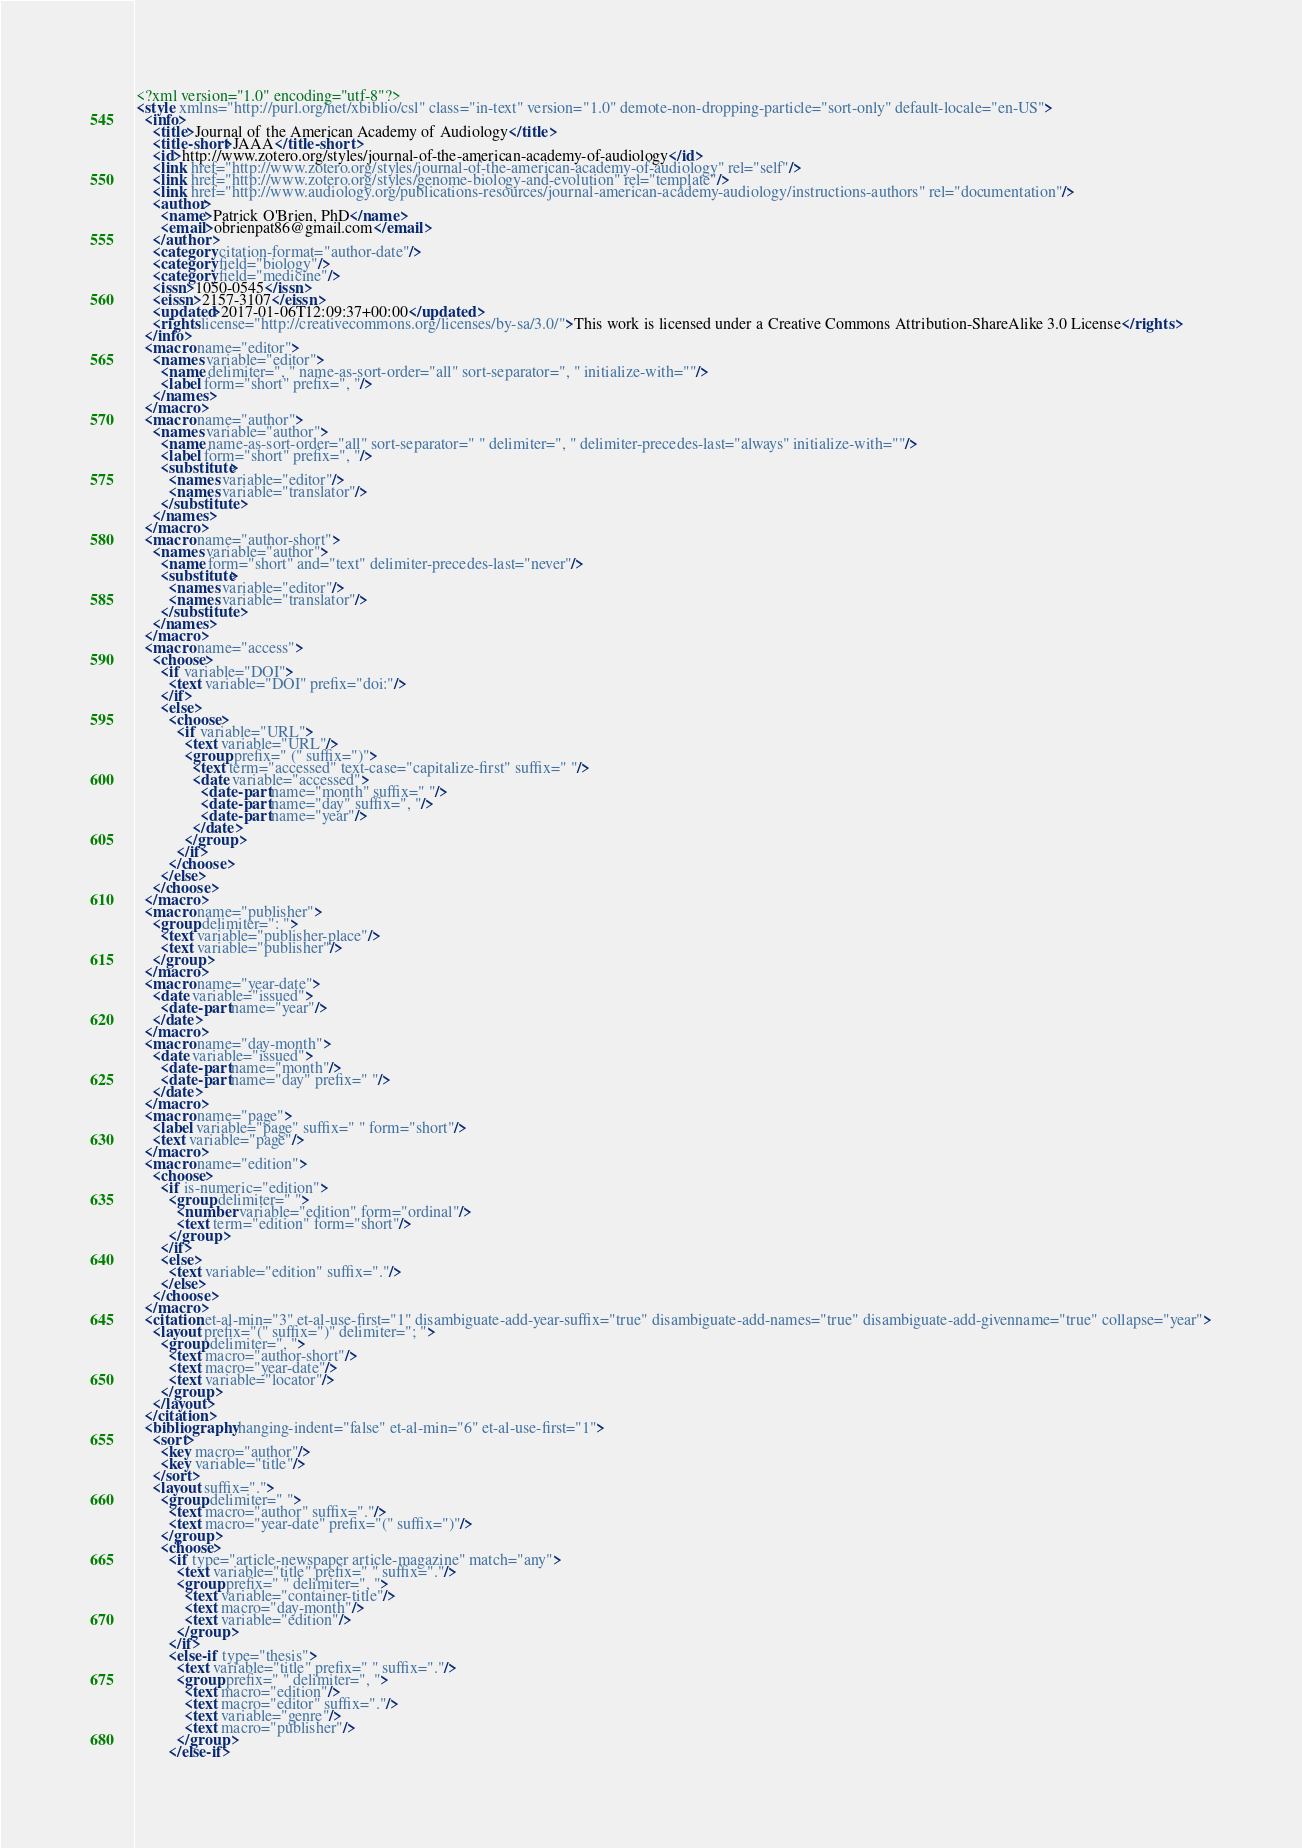<code> <loc_0><loc_0><loc_500><loc_500><_XML_><?xml version="1.0" encoding="utf-8"?>
<style xmlns="http://purl.org/net/xbiblio/csl" class="in-text" version="1.0" demote-non-dropping-particle="sort-only" default-locale="en-US">
  <info>
    <title>Journal of the American Academy of Audiology</title>
    <title-short>JAAA</title-short>
    <id>http://www.zotero.org/styles/journal-of-the-american-academy-of-audiology</id>
    <link href="http://www.zotero.org/styles/journal-of-the-american-academy-of-audiology" rel="self"/>
    <link href="http://www.zotero.org/styles/genome-biology-and-evolution" rel="template"/>
    <link href="http://www.audiology.org/publications-resources/journal-american-academy-audiology/instructions-authors" rel="documentation"/>
    <author>
      <name>Patrick O'Brien, PhD</name>
      <email>obrienpat86@gmail.com</email>
    </author>
    <category citation-format="author-date"/>
    <category field="biology"/>
    <category field="medicine"/>
    <issn>1050-0545</issn>
    <eissn>2157-3107</eissn>
    <updated>2017-01-06T12:09:37+00:00</updated>
    <rights license="http://creativecommons.org/licenses/by-sa/3.0/">This work is licensed under a Creative Commons Attribution-ShareAlike 3.0 License</rights>
  </info>
  <macro name="editor">
    <names variable="editor">
      <name delimiter=", " name-as-sort-order="all" sort-separator=", " initialize-with=""/>
      <label form="short" prefix=", "/>
    </names>
  </macro>
  <macro name="author">
    <names variable="author">
      <name name-as-sort-order="all" sort-separator=" " delimiter=", " delimiter-precedes-last="always" initialize-with=""/>
      <label form="short" prefix=", "/>
      <substitute>
        <names variable="editor"/>
        <names variable="translator"/>
      </substitute>
    </names>
  </macro>
  <macro name="author-short">
    <names variable="author">
      <name form="short" and="text" delimiter-precedes-last="never"/>
      <substitute>
        <names variable="editor"/>
        <names variable="translator"/>
      </substitute>
    </names>
  </macro>
  <macro name="access">
    <choose>
      <if variable="DOI">
        <text variable="DOI" prefix="doi:"/>
      </if>
      <else>
        <choose>
          <if variable="URL">
            <text variable="URL"/>
            <group prefix=" (" suffix=")">
              <text term="accessed" text-case="capitalize-first" suffix=" "/>
              <date variable="accessed">
                <date-part name="month" suffix=" "/>
                <date-part name="day" suffix=", "/>
                <date-part name="year"/>
              </date>
            </group>
          </if>
        </choose>
      </else>
    </choose>
  </macro>
  <macro name="publisher">
    <group delimiter=": ">
      <text variable="publisher-place"/>
      <text variable="publisher"/>
    </group>
  </macro>
  <macro name="year-date">
    <date variable="issued">
      <date-part name="year"/>
    </date>
  </macro>
  <macro name="day-month">
    <date variable="issued">
      <date-part name="month"/>
      <date-part name="day" prefix=" "/>
    </date>
  </macro>
  <macro name="page">
    <label variable="page" suffix=" " form="short"/>
    <text variable="page"/>
  </macro>
  <macro name="edition">
    <choose>
      <if is-numeric="edition">
        <group delimiter=" ">
          <number variable="edition" form="ordinal"/>
          <text term="edition" form="short"/>
        </group>
      </if>
      <else>
        <text variable="edition" suffix="."/>
      </else>
    </choose>
  </macro>
  <citation et-al-min="3" et-al-use-first="1" disambiguate-add-year-suffix="true" disambiguate-add-names="true" disambiguate-add-givenname="true" collapse="year">
    <layout prefix="(" suffix=")" delimiter="; ">
      <group delimiter=", ">
        <text macro="author-short"/>
        <text macro="year-date"/>
        <text variable="locator"/>
      </group>
    </layout>
  </citation>
  <bibliography hanging-indent="false" et-al-min="6" et-al-use-first="1">
    <sort>
      <key macro="author"/>
      <key variable="title"/>
    </sort>
    <layout suffix=".">
      <group delimiter=" ">
        <text macro="author" suffix="."/>
        <text macro="year-date" prefix="(" suffix=")"/>
      </group>
      <choose>
        <if type="article-newspaper article-magazine" match="any">
          <text variable="title" prefix=" " suffix="."/>
          <group prefix=" " delimiter=", ">
            <text variable="container-title"/>
            <text macro="day-month"/>
            <text variable="edition"/>
          </group>
        </if>
        <else-if type="thesis">
          <text variable="title" prefix=" " suffix="."/>
          <group prefix=" " delimiter=", ">
            <text macro="edition"/>
            <text macro="editor" suffix="."/>
            <text variable="genre"/>
            <text macro="publisher"/>
          </group>
        </else-if></code> 